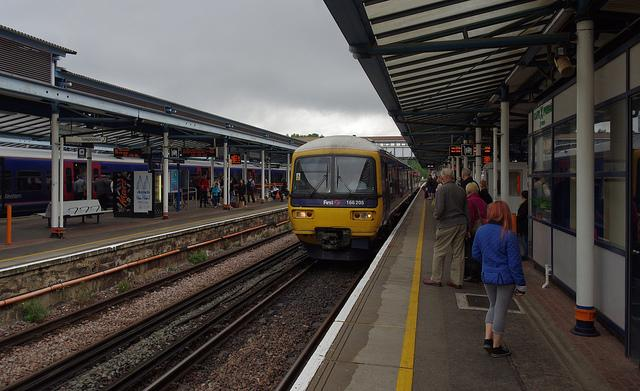At what locale do the people stand?

Choices:
A) forest station
B) train depot
C) market
D) music studios train depot 